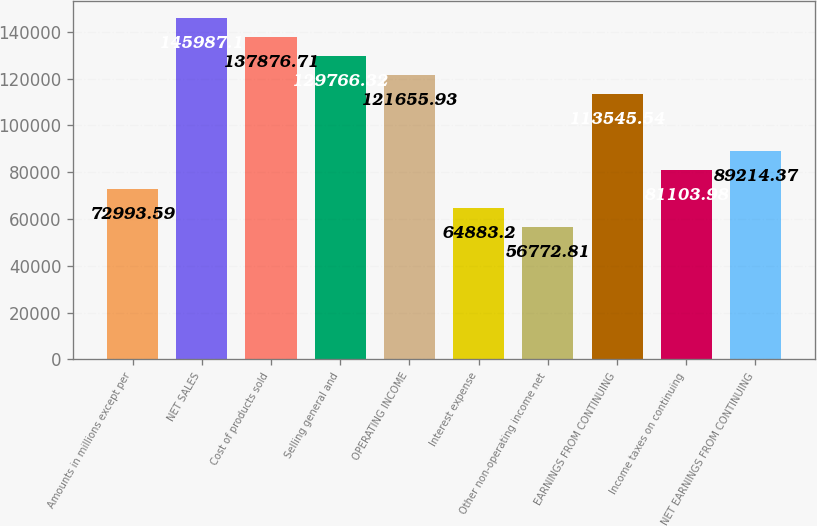Convert chart to OTSL. <chart><loc_0><loc_0><loc_500><loc_500><bar_chart><fcel>Amounts in millions except per<fcel>NET SALES<fcel>Cost of products sold<fcel>Selling general and<fcel>OPERATING INCOME<fcel>Interest expense<fcel>Other non-operating income net<fcel>EARNINGS FROM CONTINUING<fcel>Income taxes on continuing<fcel>NET EARNINGS FROM CONTINUING<nl><fcel>72993.6<fcel>145987<fcel>137877<fcel>129766<fcel>121656<fcel>64883.2<fcel>56772.8<fcel>113546<fcel>81104<fcel>89214.4<nl></chart> 